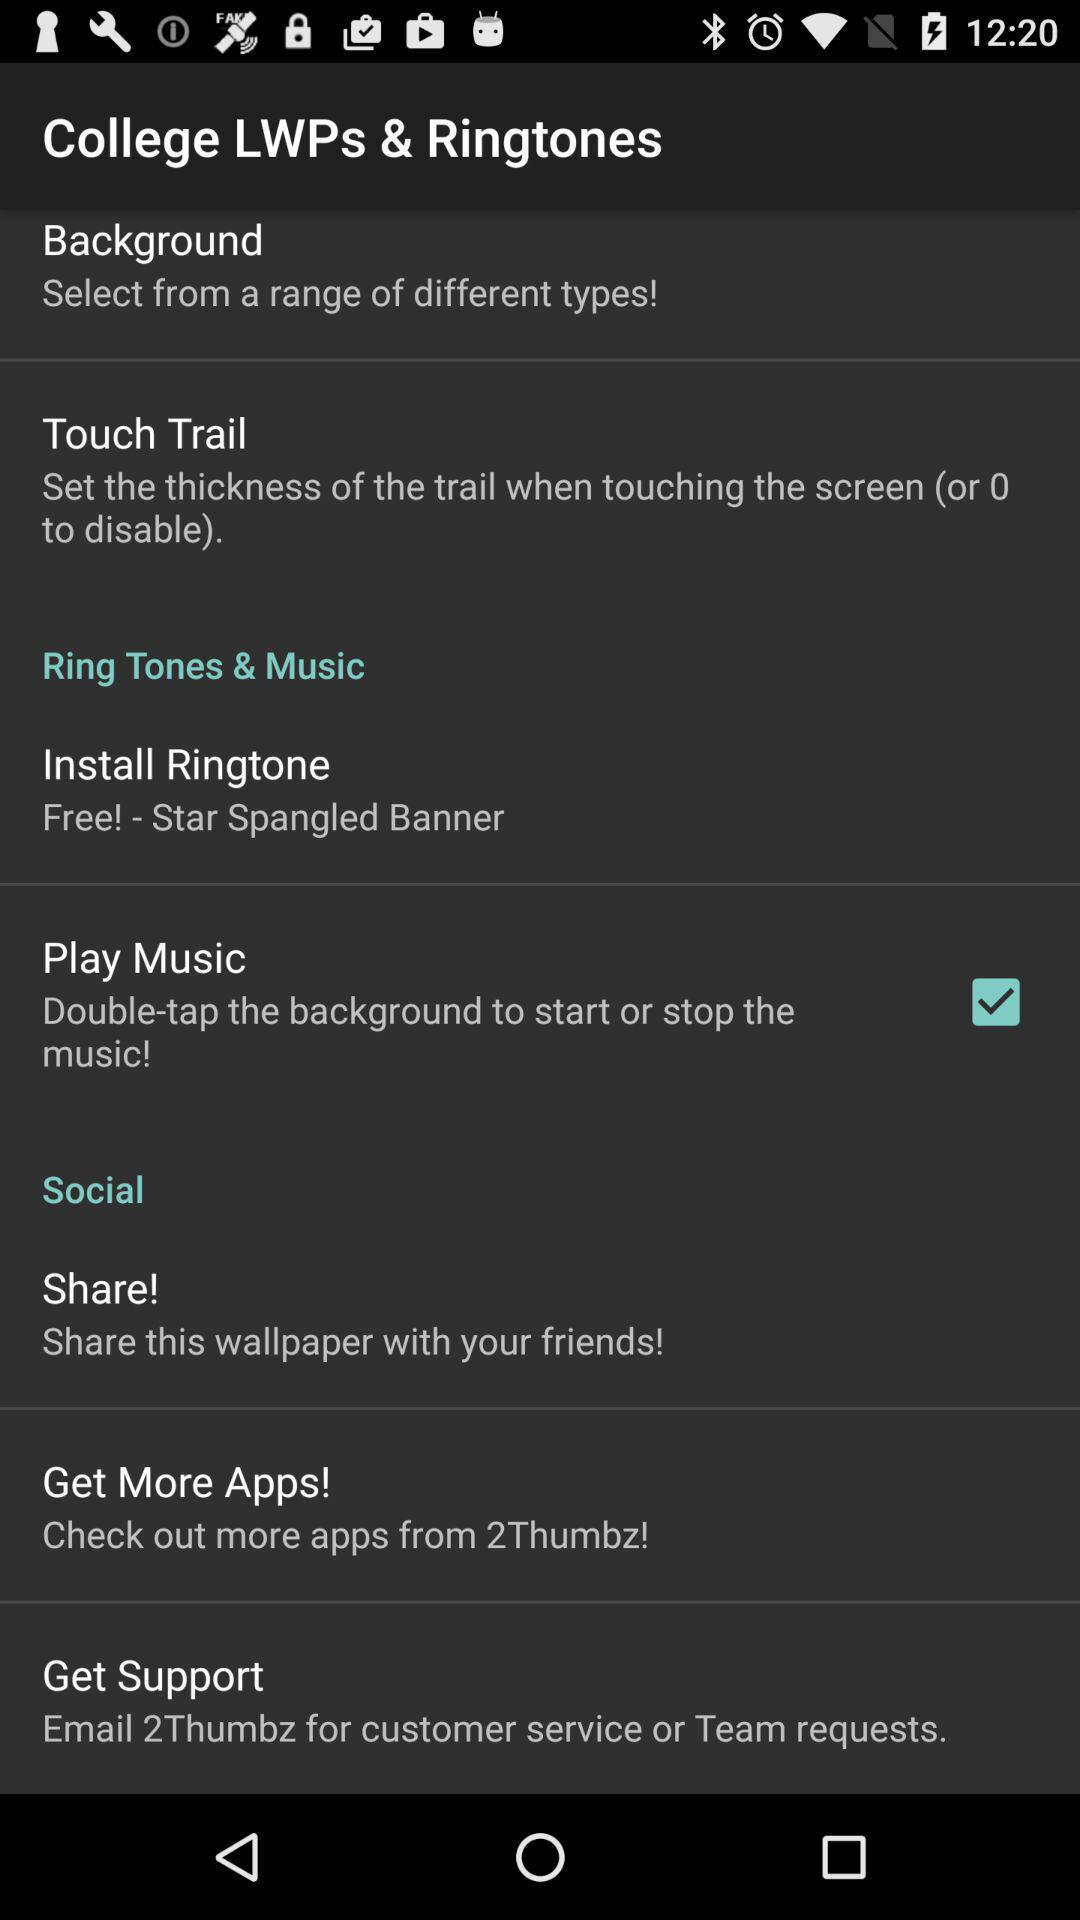What is the status of "Play Music"? The status of "Play Music" is "on". 